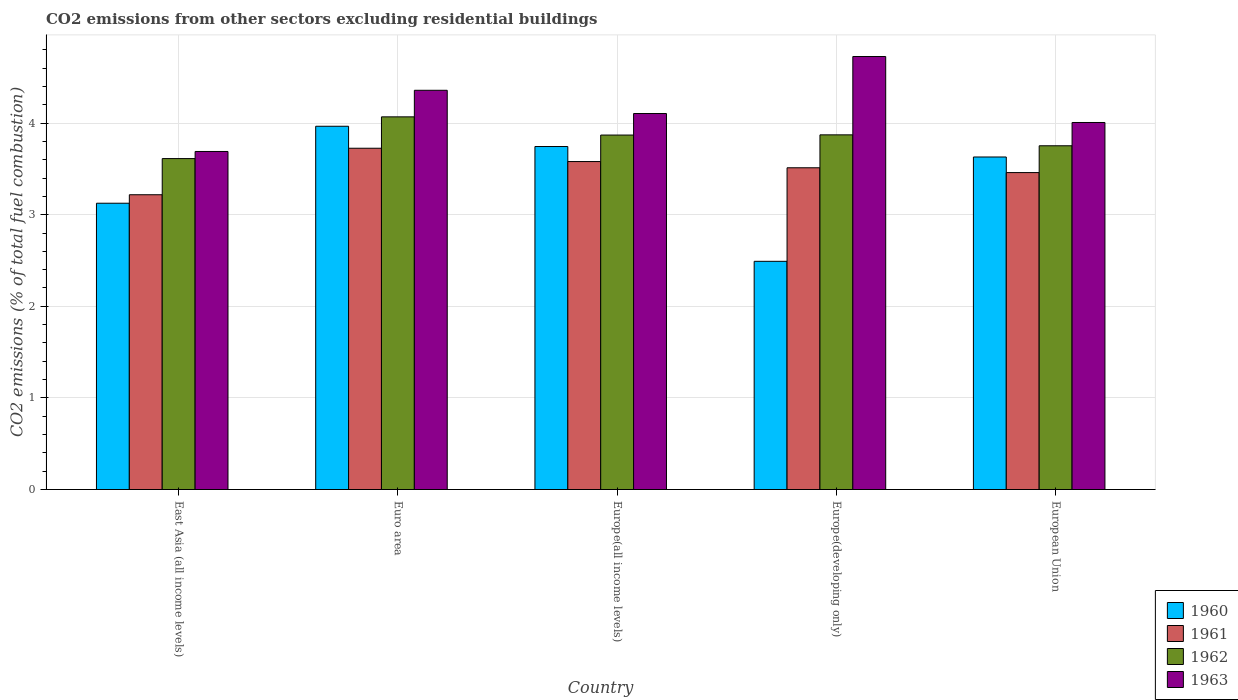How many different coloured bars are there?
Make the answer very short. 4. How many groups of bars are there?
Provide a succinct answer. 5. Are the number of bars per tick equal to the number of legend labels?
Offer a very short reply. Yes. Are the number of bars on each tick of the X-axis equal?
Ensure brevity in your answer.  Yes. How many bars are there on the 4th tick from the right?
Your answer should be compact. 4. What is the label of the 3rd group of bars from the left?
Your answer should be compact. Europe(all income levels). What is the total CO2 emitted in 1962 in Euro area?
Give a very brief answer. 4.07. Across all countries, what is the maximum total CO2 emitted in 1960?
Ensure brevity in your answer.  3.97. Across all countries, what is the minimum total CO2 emitted in 1963?
Give a very brief answer. 3.69. In which country was the total CO2 emitted in 1963 minimum?
Keep it short and to the point. East Asia (all income levels). What is the total total CO2 emitted in 1960 in the graph?
Offer a very short reply. 16.95. What is the difference between the total CO2 emitted in 1963 in Europe(developing only) and that in European Union?
Give a very brief answer. 0.72. What is the difference between the total CO2 emitted in 1962 in European Union and the total CO2 emitted in 1963 in Europe(all income levels)?
Ensure brevity in your answer.  -0.35. What is the average total CO2 emitted in 1962 per country?
Provide a short and direct response. 3.83. What is the difference between the total CO2 emitted of/in 1962 and total CO2 emitted of/in 1961 in East Asia (all income levels)?
Offer a very short reply. 0.39. In how many countries, is the total CO2 emitted in 1960 greater than 1.8?
Make the answer very short. 5. What is the ratio of the total CO2 emitted in 1962 in Europe(all income levels) to that in Europe(developing only)?
Your answer should be very brief. 1. Is the total CO2 emitted in 1961 in Europe(all income levels) less than that in Europe(developing only)?
Your answer should be very brief. No. What is the difference between the highest and the second highest total CO2 emitted in 1962?
Make the answer very short. -0. What is the difference between the highest and the lowest total CO2 emitted in 1961?
Ensure brevity in your answer.  0.51. In how many countries, is the total CO2 emitted in 1961 greater than the average total CO2 emitted in 1961 taken over all countries?
Provide a succinct answer. 3. What does the 1st bar from the right in Europe(developing only) represents?
Your answer should be very brief. 1963. How many bars are there?
Offer a very short reply. 20. Are all the bars in the graph horizontal?
Provide a succinct answer. No. Are the values on the major ticks of Y-axis written in scientific E-notation?
Your answer should be very brief. No. Does the graph contain any zero values?
Make the answer very short. No. Does the graph contain grids?
Offer a very short reply. Yes. How are the legend labels stacked?
Keep it short and to the point. Vertical. What is the title of the graph?
Provide a succinct answer. CO2 emissions from other sectors excluding residential buildings. Does "2007" appear as one of the legend labels in the graph?
Keep it short and to the point. No. What is the label or title of the X-axis?
Ensure brevity in your answer.  Country. What is the label or title of the Y-axis?
Offer a terse response. CO2 emissions (% of total fuel combustion). What is the CO2 emissions (% of total fuel combustion) of 1960 in East Asia (all income levels)?
Your response must be concise. 3.13. What is the CO2 emissions (% of total fuel combustion) in 1961 in East Asia (all income levels)?
Make the answer very short. 3.22. What is the CO2 emissions (% of total fuel combustion) in 1962 in East Asia (all income levels)?
Offer a very short reply. 3.61. What is the CO2 emissions (% of total fuel combustion) of 1963 in East Asia (all income levels)?
Make the answer very short. 3.69. What is the CO2 emissions (% of total fuel combustion) in 1960 in Euro area?
Offer a terse response. 3.97. What is the CO2 emissions (% of total fuel combustion) in 1961 in Euro area?
Offer a very short reply. 3.73. What is the CO2 emissions (% of total fuel combustion) in 1962 in Euro area?
Provide a short and direct response. 4.07. What is the CO2 emissions (% of total fuel combustion) in 1963 in Euro area?
Ensure brevity in your answer.  4.36. What is the CO2 emissions (% of total fuel combustion) of 1960 in Europe(all income levels)?
Provide a succinct answer. 3.74. What is the CO2 emissions (% of total fuel combustion) in 1961 in Europe(all income levels)?
Your answer should be compact. 3.58. What is the CO2 emissions (% of total fuel combustion) of 1962 in Europe(all income levels)?
Give a very brief answer. 3.87. What is the CO2 emissions (% of total fuel combustion) in 1963 in Europe(all income levels)?
Offer a terse response. 4.1. What is the CO2 emissions (% of total fuel combustion) in 1960 in Europe(developing only)?
Your answer should be compact. 2.49. What is the CO2 emissions (% of total fuel combustion) of 1961 in Europe(developing only)?
Give a very brief answer. 3.51. What is the CO2 emissions (% of total fuel combustion) of 1962 in Europe(developing only)?
Your answer should be very brief. 3.87. What is the CO2 emissions (% of total fuel combustion) of 1963 in Europe(developing only)?
Your answer should be very brief. 4.73. What is the CO2 emissions (% of total fuel combustion) of 1960 in European Union?
Provide a short and direct response. 3.63. What is the CO2 emissions (% of total fuel combustion) of 1961 in European Union?
Your response must be concise. 3.46. What is the CO2 emissions (% of total fuel combustion) in 1962 in European Union?
Your response must be concise. 3.75. What is the CO2 emissions (% of total fuel combustion) in 1963 in European Union?
Keep it short and to the point. 4.01. Across all countries, what is the maximum CO2 emissions (% of total fuel combustion) of 1960?
Your answer should be very brief. 3.97. Across all countries, what is the maximum CO2 emissions (% of total fuel combustion) in 1961?
Your answer should be very brief. 3.73. Across all countries, what is the maximum CO2 emissions (% of total fuel combustion) of 1962?
Provide a short and direct response. 4.07. Across all countries, what is the maximum CO2 emissions (% of total fuel combustion) of 1963?
Offer a terse response. 4.73. Across all countries, what is the minimum CO2 emissions (% of total fuel combustion) of 1960?
Offer a terse response. 2.49. Across all countries, what is the minimum CO2 emissions (% of total fuel combustion) of 1961?
Provide a succinct answer. 3.22. Across all countries, what is the minimum CO2 emissions (% of total fuel combustion) of 1962?
Provide a succinct answer. 3.61. Across all countries, what is the minimum CO2 emissions (% of total fuel combustion) of 1963?
Provide a short and direct response. 3.69. What is the total CO2 emissions (% of total fuel combustion) of 1960 in the graph?
Provide a short and direct response. 16.95. What is the total CO2 emissions (% of total fuel combustion) of 1961 in the graph?
Provide a short and direct response. 17.49. What is the total CO2 emissions (% of total fuel combustion) of 1962 in the graph?
Ensure brevity in your answer.  19.17. What is the total CO2 emissions (% of total fuel combustion) in 1963 in the graph?
Provide a succinct answer. 20.88. What is the difference between the CO2 emissions (% of total fuel combustion) in 1960 in East Asia (all income levels) and that in Euro area?
Make the answer very short. -0.84. What is the difference between the CO2 emissions (% of total fuel combustion) of 1961 in East Asia (all income levels) and that in Euro area?
Offer a very short reply. -0.51. What is the difference between the CO2 emissions (% of total fuel combustion) in 1962 in East Asia (all income levels) and that in Euro area?
Offer a terse response. -0.46. What is the difference between the CO2 emissions (% of total fuel combustion) in 1963 in East Asia (all income levels) and that in Euro area?
Your response must be concise. -0.67. What is the difference between the CO2 emissions (% of total fuel combustion) in 1960 in East Asia (all income levels) and that in Europe(all income levels)?
Provide a succinct answer. -0.62. What is the difference between the CO2 emissions (% of total fuel combustion) of 1961 in East Asia (all income levels) and that in Europe(all income levels)?
Your answer should be very brief. -0.36. What is the difference between the CO2 emissions (% of total fuel combustion) in 1962 in East Asia (all income levels) and that in Europe(all income levels)?
Offer a terse response. -0.26. What is the difference between the CO2 emissions (% of total fuel combustion) of 1963 in East Asia (all income levels) and that in Europe(all income levels)?
Offer a terse response. -0.41. What is the difference between the CO2 emissions (% of total fuel combustion) in 1960 in East Asia (all income levels) and that in Europe(developing only)?
Offer a terse response. 0.63. What is the difference between the CO2 emissions (% of total fuel combustion) of 1961 in East Asia (all income levels) and that in Europe(developing only)?
Your response must be concise. -0.29. What is the difference between the CO2 emissions (% of total fuel combustion) in 1962 in East Asia (all income levels) and that in Europe(developing only)?
Provide a short and direct response. -0.26. What is the difference between the CO2 emissions (% of total fuel combustion) in 1963 in East Asia (all income levels) and that in Europe(developing only)?
Offer a terse response. -1.04. What is the difference between the CO2 emissions (% of total fuel combustion) of 1960 in East Asia (all income levels) and that in European Union?
Provide a succinct answer. -0.5. What is the difference between the CO2 emissions (% of total fuel combustion) of 1961 in East Asia (all income levels) and that in European Union?
Keep it short and to the point. -0.24. What is the difference between the CO2 emissions (% of total fuel combustion) in 1962 in East Asia (all income levels) and that in European Union?
Offer a terse response. -0.14. What is the difference between the CO2 emissions (% of total fuel combustion) in 1963 in East Asia (all income levels) and that in European Union?
Your answer should be very brief. -0.32. What is the difference between the CO2 emissions (% of total fuel combustion) in 1960 in Euro area and that in Europe(all income levels)?
Make the answer very short. 0.22. What is the difference between the CO2 emissions (% of total fuel combustion) in 1961 in Euro area and that in Europe(all income levels)?
Keep it short and to the point. 0.15. What is the difference between the CO2 emissions (% of total fuel combustion) of 1962 in Euro area and that in Europe(all income levels)?
Provide a succinct answer. 0.2. What is the difference between the CO2 emissions (% of total fuel combustion) in 1963 in Euro area and that in Europe(all income levels)?
Offer a terse response. 0.25. What is the difference between the CO2 emissions (% of total fuel combustion) in 1960 in Euro area and that in Europe(developing only)?
Provide a short and direct response. 1.47. What is the difference between the CO2 emissions (% of total fuel combustion) of 1961 in Euro area and that in Europe(developing only)?
Keep it short and to the point. 0.21. What is the difference between the CO2 emissions (% of total fuel combustion) in 1962 in Euro area and that in Europe(developing only)?
Make the answer very short. 0.2. What is the difference between the CO2 emissions (% of total fuel combustion) of 1963 in Euro area and that in Europe(developing only)?
Give a very brief answer. -0.37. What is the difference between the CO2 emissions (% of total fuel combustion) of 1960 in Euro area and that in European Union?
Ensure brevity in your answer.  0.34. What is the difference between the CO2 emissions (% of total fuel combustion) of 1961 in Euro area and that in European Union?
Your response must be concise. 0.27. What is the difference between the CO2 emissions (% of total fuel combustion) of 1962 in Euro area and that in European Union?
Offer a very short reply. 0.32. What is the difference between the CO2 emissions (% of total fuel combustion) in 1963 in Euro area and that in European Union?
Ensure brevity in your answer.  0.35. What is the difference between the CO2 emissions (% of total fuel combustion) of 1960 in Europe(all income levels) and that in Europe(developing only)?
Offer a very short reply. 1.25. What is the difference between the CO2 emissions (% of total fuel combustion) of 1961 in Europe(all income levels) and that in Europe(developing only)?
Ensure brevity in your answer.  0.07. What is the difference between the CO2 emissions (% of total fuel combustion) of 1962 in Europe(all income levels) and that in Europe(developing only)?
Provide a short and direct response. -0. What is the difference between the CO2 emissions (% of total fuel combustion) in 1963 in Europe(all income levels) and that in Europe(developing only)?
Provide a short and direct response. -0.62. What is the difference between the CO2 emissions (% of total fuel combustion) of 1960 in Europe(all income levels) and that in European Union?
Your response must be concise. 0.11. What is the difference between the CO2 emissions (% of total fuel combustion) in 1961 in Europe(all income levels) and that in European Union?
Keep it short and to the point. 0.12. What is the difference between the CO2 emissions (% of total fuel combustion) in 1962 in Europe(all income levels) and that in European Union?
Ensure brevity in your answer.  0.12. What is the difference between the CO2 emissions (% of total fuel combustion) in 1963 in Europe(all income levels) and that in European Union?
Give a very brief answer. 0.1. What is the difference between the CO2 emissions (% of total fuel combustion) in 1960 in Europe(developing only) and that in European Union?
Give a very brief answer. -1.14. What is the difference between the CO2 emissions (% of total fuel combustion) in 1961 in Europe(developing only) and that in European Union?
Offer a very short reply. 0.05. What is the difference between the CO2 emissions (% of total fuel combustion) of 1962 in Europe(developing only) and that in European Union?
Offer a very short reply. 0.12. What is the difference between the CO2 emissions (% of total fuel combustion) of 1963 in Europe(developing only) and that in European Union?
Your response must be concise. 0.72. What is the difference between the CO2 emissions (% of total fuel combustion) of 1960 in East Asia (all income levels) and the CO2 emissions (% of total fuel combustion) of 1961 in Euro area?
Your response must be concise. -0.6. What is the difference between the CO2 emissions (% of total fuel combustion) of 1960 in East Asia (all income levels) and the CO2 emissions (% of total fuel combustion) of 1962 in Euro area?
Provide a succinct answer. -0.94. What is the difference between the CO2 emissions (% of total fuel combustion) of 1960 in East Asia (all income levels) and the CO2 emissions (% of total fuel combustion) of 1963 in Euro area?
Provide a succinct answer. -1.23. What is the difference between the CO2 emissions (% of total fuel combustion) of 1961 in East Asia (all income levels) and the CO2 emissions (% of total fuel combustion) of 1962 in Euro area?
Provide a short and direct response. -0.85. What is the difference between the CO2 emissions (% of total fuel combustion) of 1961 in East Asia (all income levels) and the CO2 emissions (% of total fuel combustion) of 1963 in Euro area?
Ensure brevity in your answer.  -1.14. What is the difference between the CO2 emissions (% of total fuel combustion) of 1962 in East Asia (all income levels) and the CO2 emissions (% of total fuel combustion) of 1963 in Euro area?
Keep it short and to the point. -0.75. What is the difference between the CO2 emissions (% of total fuel combustion) in 1960 in East Asia (all income levels) and the CO2 emissions (% of total fuel combustion) in 1961 in Europe(all income levels)?
Your response must be concise. -0.45. What is the difference between the CO2 emissions (% of total fuel combustion) in 1960 in East Asia (all income levels) and the CO2 emissions (% of total fuel combustion) in 1962 in Europe(all income levels)?
Keep it short and to the point. -0.74. What is the difference between the CO2 emissions (% of total fuel combustion) in 1960 in East Asia (all income levels) and the CO2 emissions (% of total fuel combustion) in 1963 in Europe(all income levels)?
Offer a terse response. -0.98. What is the difference between the CO2 emissions (% of total fuel combustion) in 1961 in East Asia (all income levels) and the CO2 emissions (% of total fuel combustion) in 1962 in Europe(all income levels)?
Your answer should be very brief. -0.65. What is the difference between the CO2 emissions (% of total fuel combustion) of 1961 in East Asia (all income levels) and the CO2 emissions (% of total fuel combustion) of 1963 in Europe(all income levels)?
Make the answer very short. -0.89. What is the difference between the CO2 emissions (% of total fuel combustion) in 1962 in East Asia (all income levels) and the CO2 emissions (% of total fuel combustion) in 1963 in Europe(all income levels)?
Keep it short and to the point. -0.49. What is the difference between the CO2 emissions (% of total fuel combustion) in 1960 in East Asia (all income levels) and the CO2 emissions (% of total fuel combustion) in 1961 in Europe(developing only)?
Provide a short and direct response. -0.39. What is the difference between the CO2 emissions (% of total fuel combustion) of 1960 in East Asia (all income levels) and the CO2 emissions (% of total fuel combustion) of 1962 in Europe(developing only)?
Your response must be concise. -0.75. What is the difference between the CO2 emissions (% of total fuel combustion) in 1960 in East Asia (all income levels) and the CO2 emissions (% of total fuel combustion) in 1963 in Europe(developing only)?
Provide a succinct answer. -1.6. What is the difference between the CO2 emissions (% of total fuel combustion) of 1961 in East Asia (all income levels) and the CO2 emissions (% of total fuel combustion) of 1962 in Europe(developing only)?
Offer a terse response. -0.65. What is the difference between the CO2 emissions (% of total fuel combustion) in 1961 in East Asia (all income levels) and the CO2 emissions (% of total fuel combustion) in 1963 in Europe(developing only)?
Your answer should be very brief. -1.51. What is the difference between the CO2 emissions (% of total fuel combustion) in 1962 in East Asia (all income levels) and the CO2 emissions (% of total fuel combustion) in 1963 in Europe(developing only)?
Keep it short and to the point. -1.11. What is the difference between the CO2 emissions (% of total fuel combustion) in 1960 in East Asia (all income levels) and the CO2 emissions (% of total fuel combustion) in 1961 in European Union?
Ensure brevity in your answer.  -0.33. What is the difference between the CO2 emissions (% of total fuel combustion) of 1960 in East Asia (all income levels) and the CO2 emissions (% of total fuel combustion) of 1962 in European Union?
Offer a terse response. -0.63. What is the difference between the CO2 emissions (% of total fuel combustion) in 1960 in East Asia (all income levels) and the CO2 emissions (% of total fuel combustion) in 1963 in European Union?
Offer a terse response. -0.88. What is the difference between the CO2 emissions (% of total fuel combustion) of 1961 in East Asia (all income levels) and the CO2 emissions (% of total fuel combustion) of 1962 in European Union?
Give a very brief answer. -0.53. What is the difference between the CO2 emissions (% of total fuel combustion) in 1961 in East Asia (all income levels) and the CO2 emissions (% of total fuel combustion) in 1963 in European Union?
Offer a very short reply. -0.79. What is the difference between the CO2 emissions (% of total fuel combustion) of 1962 in East Asia (all income levels) and the CO2 emissions (% of total fuel combustion) of 1963 in European Union?
Your response must be concise. -0.39. What is the difference between the CO2 emissions (% of total fuel combustion) of 1960 in Euro area and the CO2 emissions (% of total fuel combustion) of 1961 in Europe(all income levels)?
Provide a succinct answer. 0.39. What is the difference between the CO2 emissions (% of total fuel combustion) in 1960 in Euro area and the CO2 emissions (% of total fuel combustion) in 1962 in Europe(all income levels)?
Give a very brief answer. 0.1. What is the difference between the CO2 emissions (% of total fuel combustion) of 1960 in Euro area and the CO2 emissions (% of total fuel combustion) of 1963 in Europe(all income levels)?
Offer a terse response. -0.14. What is the difference between the CO2 emissions (% of total fuel combustion) of 1961 in Euro area and the CO2 emissions (% of total fuel combustion) of 1962 in Europe(all income levels)?
Offer a terse response. -0.14. What is the difference between the CO2 emissions (% of total fuel combustion) in 1961 in Euro area and the CO2 emissions (% of total fuel combustion) in 1963 in Europe(all income levels)?
Offer a very short reply. -0.38. What is the difference between the CO2 emissions (% of total fuel combustion) in 1962 in Euro area and the CO2 emissions (% of total fuel combustion) in 1963 in Europe(all income levels)?
Make the answer very short. -0.04. What is the difference between the CO2 emissions (% of total fuel combustion) in 1960 in Euro area and the CO2 emissions (% of total fuel combustion) in 1961 in Europe(developing only)?
Your response must be concise. 0.45. What is the difference between the CO2 emissions (% of total fuel combustion) in 1960 in Euro area and the CO2 emissions (% of total fuel combustion) in 1962 in Europe(developing only)?
Ensure brevity in your answer.  0.09. What is the difference between the CO2 emissions (% of total fuel combustion) of 1960 in Euro area and the CO2 emissions (% of total fuel combustion) of 1963 in Europe(developing only)?
Your answer should be very brief. -0.76. What is the difference between the CO2 emissions (% of total fuel combustion) in 1961 in Euro area and the CO2 emissions (% of total fuel combustion) in 1962 in Europe(developing only)?
Provide a succinct answer. -0.15. What is the difference between the CO2 emissions (% of total fuel combustion) in 1961 in Euro area and the CO2 emissions (% of total fuel combustion) in 1963 in Europe(developing only)?
Your response must be concise. -1. What is the difference between the CO2 emissions (% of total fuel combustion) in 1962 in Euro area and the CO2 emissions (% of total fuel combustion) in 1963 in Europe(developing only)?
Provide a short and direct response. -0.66. What is the difference between the CO2 emissions (% of total fuel combustion) in 1960 in Euro area and the CO2 emissions (% of total fuel combustion) in 1961 in European Union?
Provide a short and direct response. 0.51. What is the difference between the CO2 emissions (% of total fuel combustion) in 1960 in Euro area and the CO2 emissions (% of total fuel combustion) in 1962 in European Union?
Provide a succinct answer. 0.21. What is the difference between the CO2 emissions (% of total fuel combustion) of 1960 in Euro area and the CO2 emissions (% of total fuel combustion) of 1963 in European Union?
Your answer should be compact. -0.04. What is the difference between the CO2 emissions (% of total fuel combustion) in 1961 in Euro area and the CO2 emissions (% of total fuel combustion) in 1962 in European Union?
Your answer should be very brief. -0.03. What is the difference between the CO2 emissions (% of total fuel combustion) of 1961 in Euro area and the CO2 emissions (% of total fuel combustion) of 1963 in European Union?
Give a very brief answer. -0.28. What is the difference between the CO2 emissions (% of total fuel combustion) in 1962 in Euro area and the CO2 emissions (% of total fuel combustion) in 1963 in European Union?
Provide a succinct answer. 0.06. What is the difference between the CO2 emissions (% of total fuel combustion) of 1960 in Europe(all income levels) and the CO2 emissions (% of total fuel combustion) of 1961 in Europe(developing only)?
Your response must be concise. 0.23. What is the difference between the CO2 emissions (% of total fuel combustion) of 1960 in Europe(all income levels) and the CO2 emissions (% of total fuel combustion) of 1962 in Europe(developing only)?
Keep it short and to the point. -0.13. What is the difference between the CO2 emissions (% of total fuel combustion) in 1960 in Europe(all income levels) and the CO2 emissions (% of total fuel combustion) in 1963 in Europe(developing only)?
Your answer should be compact. -0.98. What is the difference between the CO2 emissions (% of total fuel combustion) in 1961 in Europe(all income levels) and the CO2 emissions (% of total fuel combustion) in 1962 in Europe(developing only)?
Provide a succinct answer. -0.29. What is the difference between the CO2 emissions (% of total fuel combustion) of 1961 in Europe(all income levels) and the CO2 emissions (% of total fuel combustion) of 1963 in Europe(developing only)?
Give a very brief answer. -1.15. What is the difference between the CO2 emissions (% of total fuel combustion) of 1962 in Europe(all income levels) and the CO2 emissions (% of total fuel combustion) of 1963 in Europe(developing only)?
Give a very brief answer. -0.86. What is the difference between the CO2 emissions (% of total fuel combustion) in 1960 in Europe(all income levels) and the CO2 emissions (% of total fuel combustion) in 1961 in European Union?
Make the answer very short. 0.28. What is the difference between the CO2 emissions (% of total fuel combustion) of 1960 in Europe(all income levels) and the CO2 emissions (% of total fuel combustion) of 1962 in European Union?
Make the answer very short. -0.01. What is the difference between the CO2 emissions (% of total fuel combustion) in 1960 in Europe(all income levels) and the CO2 emissions (% of total fuel combustion) in 1963 in European Union?
Your response must be concise. -0.26. What is the difference between the CO2 emissions (% of total fuel combustion) of 1961 in Europe(all income levels) and the CO2 emissions (% of total fuel combustion) of 1962 in European Union?
Provide a short and direct response. -0.17. What is the difference between the CO2 emissions (% of total fuel combustion) of 1961 in Europe(all income levels) and the CO2 emissions (% of total fuel combustion) of 1963 in European Union?
Make the answer very short. -0.43. What is the difference between the CO2 emissions (% of total fuel combustion) in 1962 in Europe(all income levels) and the CO2 emissions (% of total fuel combustion) in 1963 in European Union?
Make the answer very short. -0.14. What is the difference between the CO2 emissions (% of total fuel combustion) of 1960 in Europe(developing only) and the CO2 emissions (% of total fuel combustion) of 1961 in European Union?
Ensure brevity in your answer.  -0.97. What is the difference between the CO2 emissions (% of total fuel combustion) of 1960 in Europe(developing only) and the CO2 emissions (% of total fuel combustion) of 1962 in European Union?
Provide a short and direct response. -1.26. What is the difference between the CO2 emissions (% of total fuel combustion) of 1960 in Europe(developing only) and the CO2 emissions (% of total fuel combustion) of 1963 in European Union?
Provide a short and direct response. -1.52. What is the difference between the CO2 emissions (% of total fuel combustion) of 1961 in Europe(developing only) and the CO2 emissions (% of total fuel combustion) of 1962 in European Union?
Your answer should be very brief. -0.24. What is the difference between the CO2 emissions (% of total fuel combustion) of 1961 in Europe(developing only) and the CO2 emissions (% of total fuel combustion) of 1963 in European Union?
Ensure brevity in your answer.  -0.49. What is the difference between the CO2 emissions (% of total fuel combustion) in 1962 in Europe(developing only) and the CO2 emissions (% of total fuel combustion) in 1963 in European Union?
Provide a short and direct response. -0.14. What is the average CO2 emissions (% of total fuel combustion) in 1960 per country?
Provide a short and direct response. 3.39. What is the average CO2 emissions (% of total fuel combustion) of 1961 per country?
Provide a succinct answer. 3.5. What is the average CO2 emissions (% of total fuel combustion) of 1962 per country?
Your answer should be compact. 3.83. What is the average CO2 emissions (% of total fuel combustion) of 1963 per country?
Keep it short and to the point. 4.18. What is the difference between the CO2 emissions (% of total fuel combustion) of 1960 and CO2 emissions (% of total fuel combustion) of 1961 in East Asia (all income levels)?
Ensure brevity in your answer.  -0.09. What is the difference between the CO2 emissions (% of total fuel combustion) in 1960 and CO2 emissions (% of total fuel combustion) in 1962 in East Asia (all income levels)?
Keep it short and to the point. -0.49. What is the difference between the CO2 emissions (% of total fuel combustion) in 1960 and CO2 emissions (% of total fuel combustion) in 1963 in East Asia (all income levels)?
Your response must be concise. -0.56. What is the difference between the CO2 emissions (% of total fuel combustion) of 1961 and CO2 emissions (% of total fuel combustion) of 1962 in East Asia (all income levels)?
Make the answer very short. -0.39. What is the difference between the CO2 emissions (% of total fuel combustion) of 1961 and CO2 emissions (% of total fuel combustion) of 1963 in East Asia (all income levels)?
Ensure brevity in your answer.  -0.47. What is the difference between the CO2 emissions (% of total fuel combustion) of 1962 and CO2 emissions (% of total fuel combustion) of 1963 in East Asia (all income levels)?
Offer a very short reply. -0.08. What is the difference between the CO2 emissions (% of total fuel combustion) in 1960 and CO2 emissions (% of total fuel combustion) in 1961 in Euro area?
Keep it short and to the point. 0.24. What is the difference between the CO2 emissions (% of total fuel combustion) in 1960 and CO2 emissions (% of total fuel combustion) in 1962 in Euro area?
Ensure brevity in your answer.  -0.1. What is the difference between the CO2 emissions (% of total fuel combustion) of 1960 and CO2 emissions (% of total fuel combustion) of 1963 in Euro area?
Your answer should be compact. -0.39. What is the difference between the CO2 emissions (% of total fuel combustion) of 1961 and CO2 emissions (% of total fuel combustion) of 1962 in Euro area?
Keep it short and to the point. -0.34. What is the difference between the CO2 emissions (% of total fuel combustion) of 1961 and CO2 emissions (% of total fuel combustion) of 1963 in Euro area?
Offer a terse response. -0.63. What is the difference between the CO2 emissions (% of total fuel combustion) in 1962 and CO2 emissions (% of total fuel combustion) in 1963 in Euro area?
Ensure brevity in your answer.  -0.29. What is the difference between the CO2 emissions (% of total fuel combustion) of 1960 and CO2 emissions (% of total fuel combustion) of 1961 in Europe(all income levels)?
Provide a short and direct response. 0.16. What is the difference between the CO2 emissions (% of total fuel combustion) of 1960 and CO2 emissions (% of total fuel combustion) of 1962 in Europe(all income levels)?
Offer a terse response. -0.13. What is the difference between the CO2 emissions (% of total fuel combustion) of 1960 and CO2 emissions (% of total fuel combustion) of 1963 in Europe(all income levels)?
Offer a terse response. -0.36. What is the difference between the CO2 emissions (% of total fuel combustion) of 1961 and CO2 emissions (% of total fuel combustion) of 1962 in Europe(all income levels)?
Provide a succinct answer. -0.29. What is the difference between the CO2 emissions (% of total fuel combustion) of 1961 and CO2 emissions (% of total fuel combustion) of 1963 in Europe(all income levels)?
Ensure brevity in your answer.  -0.52. What is the difference between the CO2 emissions (% of total fuel combustion) in 1962 and CO2 emissions (% of total fuel combustion) in 1963 in Europe(all income levels)?
Provide a short and direct response. -0.23. What is the difference between the CO2 emissions (% of total fuel combustion) in 1960 and CO2 emissions (% of total fuel combustion) in 1961 in Europe(developing only)?
Your answer should be very brief. -1.02. What is the difference between the CO2 emissions (% of total fuel combustion) of 1960 and CO2 emissions (% of total fuel combustion) of 1962 in Europe(developing only)?
Offer a terse response. -1.38. What is the difference between the CO2 emissions (% of total fuel combustion) of 1960 and CO2 emissions (% of total fuel combustion) of 1963 in Europe(developing only)?
Make the answer very short. -2.24. What is the difference between the CO2 emissions (% of total fuel combustion) of 1961 and CO2 emissions (% of total fuel combustion) of 1962 in Europe(developing only)?
Your response must be concise. -0.36. What is the difference between the CO2 emissions (% of total fuel combustion) of 1961 and CO2 emissions (% of total fuel combustion) of 1963 in Europe(developing only)?
Your answer should be very brief. -1.21. What is the difference between the CO2 emissions (% of total fuel combustion) of 1962 and CO2 emissions (% of total fuel combustion) of 1963 in Europe(developing only)?
Keep it short and to the point. -0.85. What is the difference between the CO2 emissions (% of total fuel combustion) in 1960 and CO2 emissions (% of total fuel combustion) in 1961 in European Union?
Your answer should be very brief. 0.17. What is the difference between the CO2 emissions (% of total fuel combustion) of 1960 and CO2 emissions (% of total fuel combustion) of 1962 in European Union?
Offer a very short reply. -0.12. What is the difference between the CO2 emissions (% of total fuel combustion) of 1960 and CO2 emissions (% of total fuel combustion) of 1963 in European Union?
Provide a succinct answer. -0.38. What is the difference between the CO2 emissions (% of total fuel combustion) in 1961 and CO2 emissions (% of total fuel combustion) in 1962 in European Union?
Provide a succinct answer. -0.29. What is the difference between the CO2 emissions (% of total fuel combustion) in 1961 and CO2 emissions (% of total fuel combustion) in 1963 in European Union?
Provide a succinct answer. -0.55. What is the difference between the CO2 emissions (% of total fuel combustion) of 1962 and CO2 emissions (% of total fuel combustion) of 1963 in European Union?
Your response must be concise. -0.25. What is the ratio of the CO2 emissions (% of total fuel combustion) in 1960 in East Asia (all income levels) to that in Euro area?
Ensure brevity in your answer.  0.79. What is the ratio of the CO2 emissions (% of total fuel combustion) of 1961 in East Asia (all income levels) to that in Euro area?
Your answer should be very brief. 0.86. What is the ratio of the CO2 emissions (% of total fuel combustion) in 1962 in East Asia (all income levels) to that in Euro area?
Offer a very short reply. 0.89. What is the ratio of the CO2 emissions (% of total fuel combustion) of 1963 in East Asia (all income levels) to that in Euro area?
Offer a terse response. 0.85. What is the ratio of the CO2 emissions (% of total fuel combustion) in 1960 in East Asia (all income levels) to that in Europe(all income levels)?
Make the answer very short. 0.83. What is the ratio of the CO2 emissions (% of total fuel combustion) of 1961 in East Asia (all income levels) to that in Europe(all income levels)?
Offer a terse response. 0.9. What is the ratio of the CO2 emissions (% of total fuel combustion) of 1962 in East Asia (all income levels) to that in Europe(all income levels)?
Ensure brevity in your answer.  0.93. What is the ratio of the CO2 emissions (% of total fuel combustion) in 1963 in East Asia (all income levels) to that in Europe(all income levels)?
Your answer should be compact. 0.9. What is the ratio of the CO2 emissions (% of total fuel combustion) of 1960 in East Asia (all income levels) to that in Europe(developing only)?
Your response must be concise. 1.25. What is the ratio of the CO2 emissions (% of total fuel combustion) in 1961 in East Asia (all income levels) to that in Europe(developing only)?
Give a very brief answer. 0.92. What is the ratio of the CO2 emissions (% of total fuel combustion) of 1962 in East Asia (all income levels) to that in Europe(developing only)?
Offer a terse response. 0.93. What is the ratio of the CO2 emissions (% of total fuel combustion) in 1963 in East Asia (all income levels) to that in Europe(developing only)?
Offer a very short reply. 0.78. What is the ratio of the CO2 emissions (% of total fuel combustion) of 1960 in East Asia (all income levels) to that in European Union?
Offer a very short reply. 0.86. What is the ratio of the CO2 emissions (% of total fuel combustion) in 1961 in East Asia (all income levels) to that in European Union?
Provide a short and direct response. 0.93. What is the ratio of the CO2 emissions (% of total fuel combustion) in 1962 in East Asia (all income levels) to that in European Union?
Give a very brief answer. 0.96. What is the ratio of the CO2 emissions (% of total fuel combustion) of 1963 in East Asia (all income levels) to that in European Union?
Your response must be concise. 0.92. What is the ratio of the CO2 emissions (% of total fuel combustion) of 1960 in Euro area to that in Europe(all income levels)?
Your response must be concise. 1.06. What is the ratio of the CO2 emissions (% of total fuel combustion) in 1961 in Euro area to that in Europe(all income levels)?
Ensure brevity in your answer.  1.04. What is the ratio of the CO2 emissions (% of total fuel combustion) of 1962 in Euro area to that in Europe(all income levels)?
Give a very brief answer. 1.05. What is the ratio of the CO2 emissions (% of total fuel combustion) in 1963 in Euro area to that in Europe(all income levels)?
Offer a very short reply. 1.06. What is the ratio of the CO2 emissions (% of total fuel combustion) of 1960 in Euro area to that in Europe(developing only)?
Ensure brevity in your answer.  1.59. What is the ratio of the CO2 emissions (% of total fuel combustion) of 1961 in Euro area to that in Europe(developing only)?
Offer a terse response. 1.06. What is the ratio of the CO2 emissions (% of total fuel combustion) in 1962 in Euro area to that in Europe(developing only)?
Give a very brief answer. 1.05. What is the ratio of the CO2 emissions (% of total fuel combustion) of 1963 in Euro area to that in Europe(developing only)?
Make the answer very short. 0.92. What is the ratio of the CO2 emissions (% of total fuel combustion) in 1960 in Euro area to that in European Union?
Offer a very short reply. 1.09. What is the ratio of the CO2 emissions (% of total fuel combustion) in 1961 in Euro area to that in European Union?
Provide a short and direct response. 1.08. What is the ratio of the CO2 emissions (% of total fuel combustion) in 1962 in Euro area to that in European Union?
Ensure brevity in your answer.  1.08. What is the ratio of the CO2 emissions (% of total fuel combustion) in 1963 in Euro area to that in European Union?
Make the answer very short. 1.09. What is the ratio of the CO2 emissions (% of total fuel combustion) in 1960 in Europe(all income levels) to that in Europe(developing only)?
Make the answer very short. 1.5. What is the ratio of the CO2 emissions (% of total fuel combustion) of 1961 in Europe(all income levels) to that in Europe(developing only)?
Your response must be concise. 1.02. What is the ratio of the CO2 emissions (% of total fuel combustion) of 1962 in Europe(all income levels) to that in Europe(developing only)?
Make the answer very short. 1. What is the ratio of the CO2 emissions (% of total fuel combustion) of 1963 in Europe(all income levels) to that in Europe(developing only)?
Make the answer very short. 0.87. What is the ratio of the CO2 emissions (% of total fuel combustion) in 1960 in Europe(all income levels) to that in European Union?
Keep it short and to the point. 1.03. What is the ratio of the CO2 emissions (% of total fuel combustion) of 1961 in Europe(all income levels) to that in European Union?
Your answer should be very brief. 1.03. What is the ratio of the CO2 emissions (% of total fuel combustion) in 1962 in Europe(all income levels) to that in European Union?
Give a very brief answer. 1.03. What is the ratio of the CO2 emissions (% of total fuel combustion) in 1963 in Europe(all income levels) to that in European Union?
Provide a short and direct response. 1.02. What is the ratio of the CO2 emissions (% of total fuel combustion) in 1960 in Europe(developing only) to that in European Union?
Keep it short and to the point. 0.69. What is the ratio of the CO2 emissions (% of total fuel combustion) in 1961 in Europe(developing only) to that in European Union?
Ensure brevity in your answer.  1.02. What is the ratio of the CO2 emissions (% of total fuel combustion) of 1962 in Europe(developing only) to that in European Union?
Ensure brevity in your answer.  1.03. What is the ratio of the CO2 emissions (% of total fuel combustion) of 1963 in Europe(developing only) to that in European Union?
Keep it short and to the point. 1.18. What is the difference between the highest and the second highest CO2 emissions (% of total fuel combustion) of 1960?
Make the answer very short. 0.22. What is the difference between the highest and the second highest CO2 emissions (% of total fuel combustion) of 1961?
Make the answer very short. 0.15. What is the difference between the highest and the second highest CO2 emissions (% of total fuel combustion) in 1962?
Ensure brevity in your answer.  0.2. What is the difference between the highest and the second highest CO2 emissions (% of total fuel combustion) in 1963?
Give a very brief answer. 0.37. What is the difference between the highest and the lowest CO2 emissions (% of total fuel combustion) of 1960?
Offer a very short reply. 1.47. What is the difference between the highest and the lowest CO2 emissions (% of total fuel combustion) of 1961?
Make the answer very short. 0.51. What is the difference between the highest and the lowest CO2 emissions (% of total fuel combustion) in 1962?
Your answer should be compact. 0.46. What is the difference between the highest and the lowest CO2 emissions (% of total fuel combustion) of 1963?
Provide a succinct answer. 1.04. 